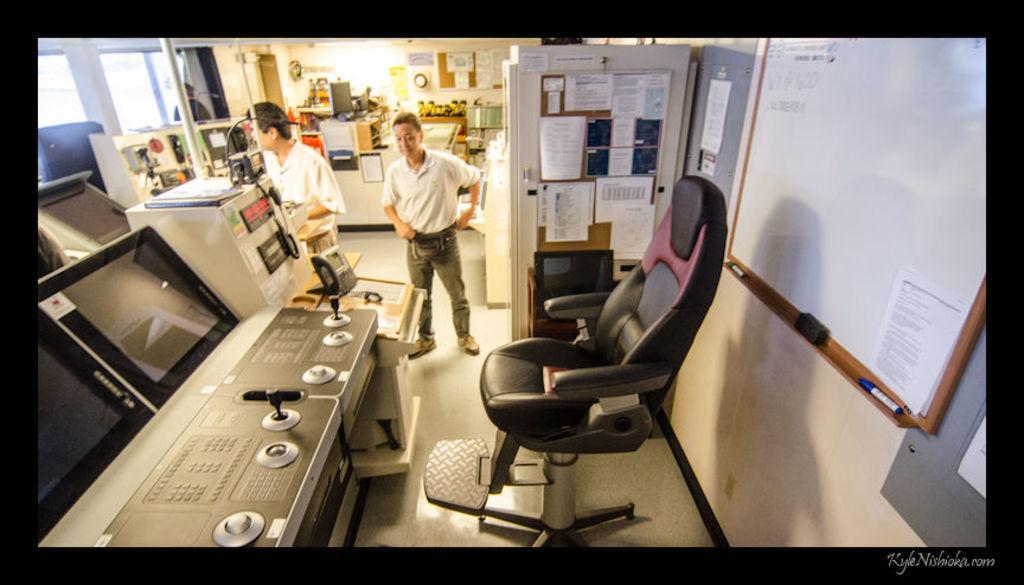Describe this image in one or two sentences. In this image In the middle there is a man he wear t shirt, trouser and shoes. On the right there is a chair, whiteboard, marker and paper. On the left there is a screen and paper. 